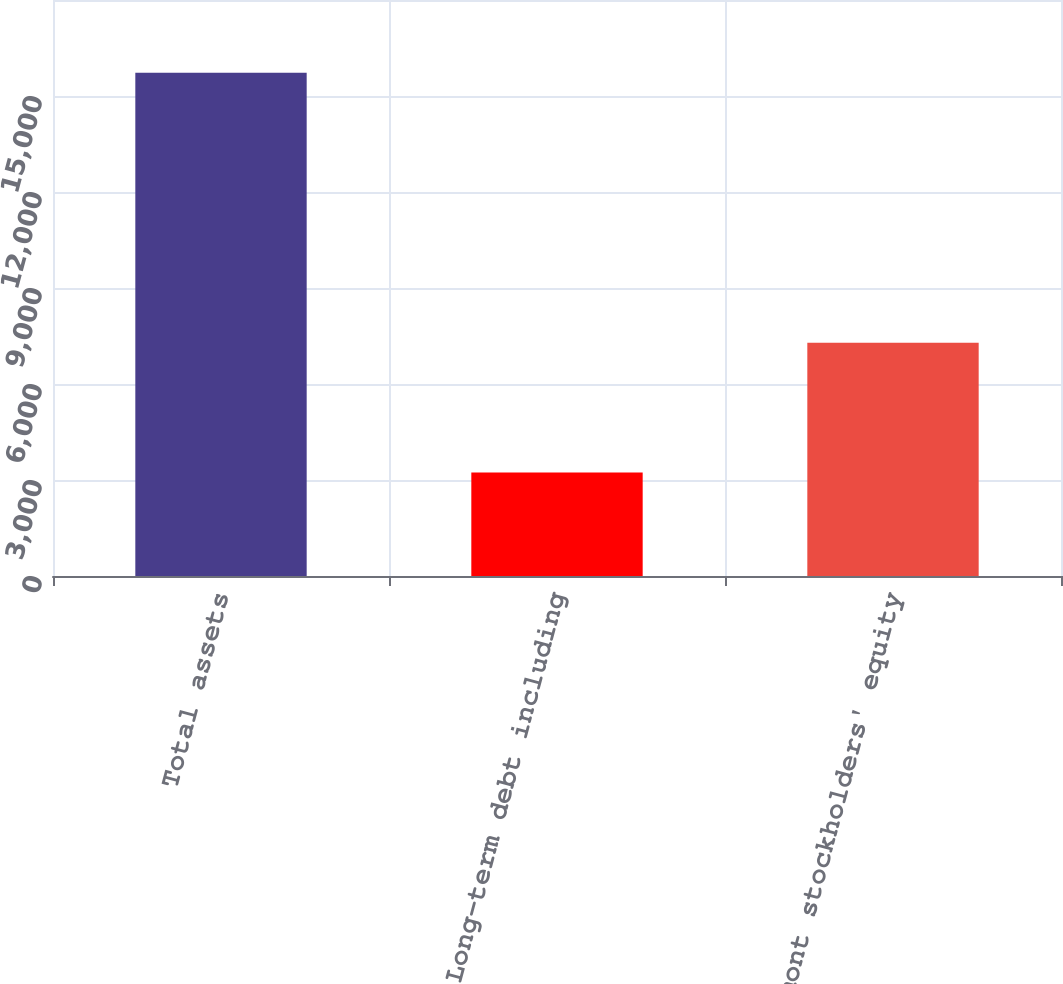Convert chart. <chart><loc_0><loc_0><loc_500><loc_500><bar_chart><fcel>Total assets<fcel>Long-term debt including<fcel>Newmont stockholders' equity<nl><fcel>15727<fcel>3237<fcel>7291<nl></chart> 